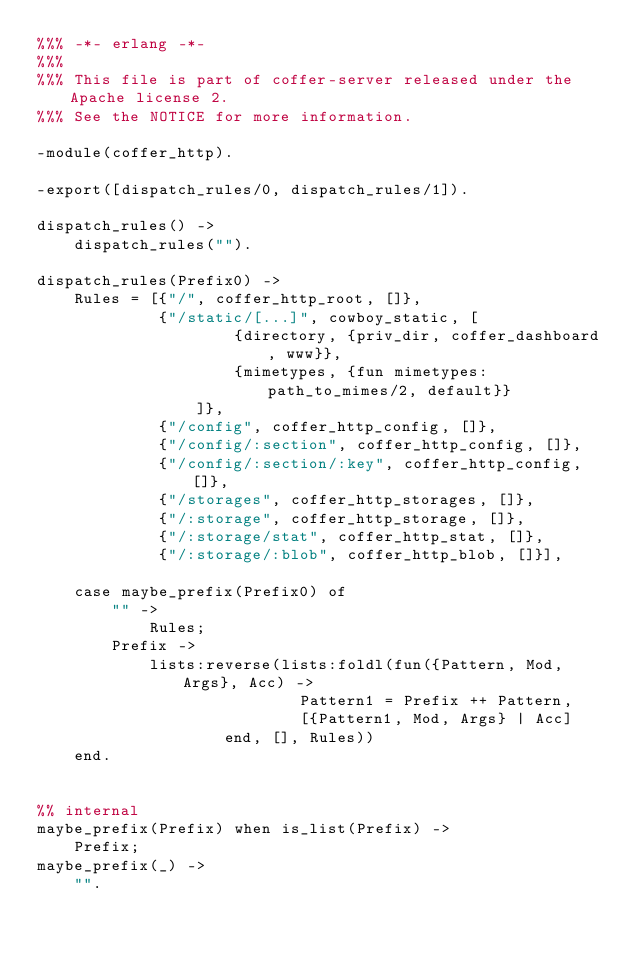<code> <loc_0><loc_0><loc_500><loc_500><_Erlang_>%%% -*- erlang -*-
%%%
%%% This file is part of coffer-server released under the Apache license 2.
%%% See the NOTICE for more information.

-module(coffer_http).

-export([dispatch_rules/0, dispatch_rules/1]).

dispatch_rules() ->
    dispatch_rules("").

dispatch_rules(Prefix0) ->
    Rules = [{"/", coffer_http_root, []},
             {"/static/[...]", cowboy_static, [
                     {directory, {priv_dir, coffer_dashboard, www}},
                     {mimetypes, {fun mimetypes:path_to_mimes/2, default}}
                 ]},
             {"/config", coffer_http_config, []},
             {"/config/:section", coffer_http_config, []},
             {"/config/:section/:key", coffer_http_config, []},
             {"/storages", coffer_http_storages, []},
             {"/:storage", coffer_http_storage, []},
             {"/:storage/stat", coffer_http_stat, []},
             {"/:storage/:blob", coffer_http_blob, []}],

    case maybe_prefix(Prefix0) of
        "" ->
            Rules;
        Prefix ->
            lists:reverse(lists:foldl(fun({Pattern, Mod, Args}, Acc) ->
                            Pattern1 = Prefix ++ Pattern,
                            [{Pattern1, Mod, Args} | Acc]
                    end, [], Rules))
    end.


%% internal
maybe_prefix(Prefix) when is_list(Prefix) ->
    Prefix;
maybe_prefix(_) ->
    "".
</code> 